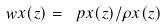<formula> <loc_0><loc_0><loc_500><loc_500>\ w x ( z ) = \ p x ( z ) / \rho x ( z )</formula> 